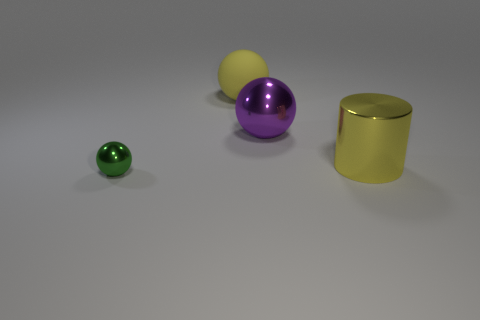Add 1 gray metallic objects. How many objects exist? 5 Subtract all spheres. How many objects are left? 1 Add 1 large shiny spheres. How many large shiny spheres are left? 2 Add 2 metal spheres. How many metal spheres exist? 4 Subtract 0 blue cubes. How many objects are left? 4 Subtract all big rubber spheres. Subtract all green metal things. How many objects are left? 2 